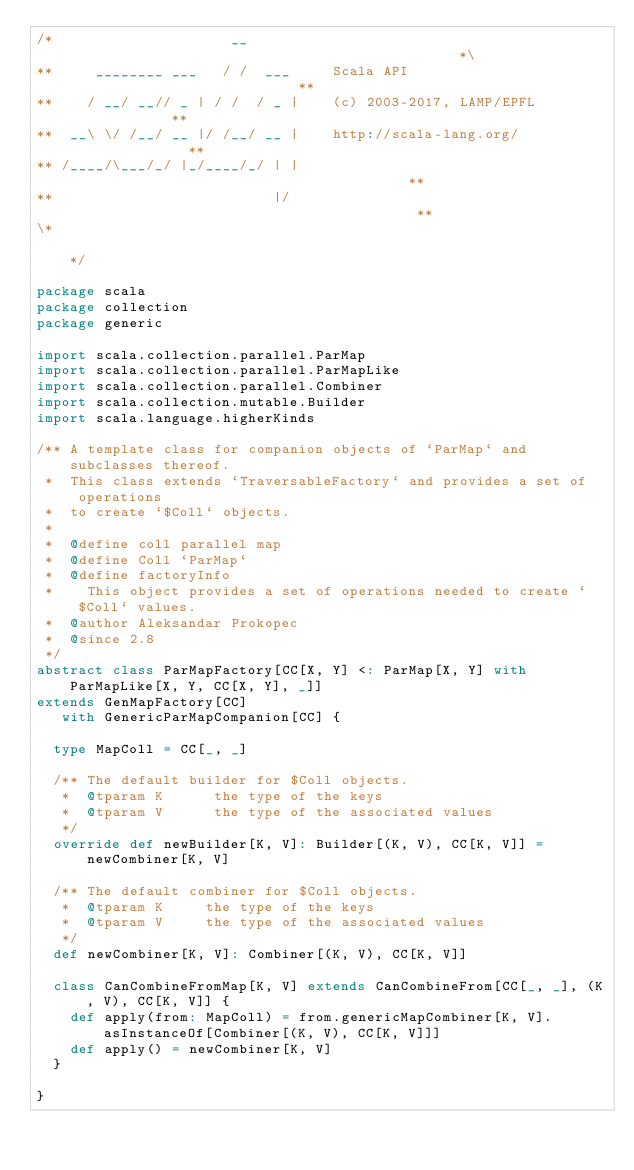<code> <loc_0><loc_0><loc_500><loc_500><_Scala_>/*                     __                                               *\
**     ________ ___   / /  ___     Scala API                            **
**    / __/ __// _ | / /  / _ |    (c) 2003-2017, LAMP/EPFL             **
**  __\ \/ /__/ __ |/ /__/ __ |    http://scala-lang.org/               **
** /____/\___/_/ |_/____/_/ | |                                         **
**                          |/                                          **
\*                                                                      */

package scala
package collection
package generic

import scala.collection.parallel.ParMap
import scala.collection.parallel.ParMapLike
import scala.collection.parallel.Combiner
import scala.collection.mutable.Builder
import scala.language.higherKinds

/** A template class for companion objects of `ParMap` and subclasses thereof.
 *  This class extends `TraversableFactory` and provides a set of operations
 *  to create `$Coll` objects.
 *
 *  @define coll parallel map
 *  @define Coll `ParMap`
 *  @define factoryInfo
 *    This object provides a set of operations needed to create `$Coll` values.
 *  @author Aleksandar Prokopec
 *  @since 2.8
 */
abstract class ParMapFactory[CC[X, Y] <: ParMap[X, Y] with ParMapLike[X, Y, CC[X, Y], _]]
extends GenMapFactory[CC]
   with GenericParMapCompanion[CC] {

  type MapColl = CC[_, _]

  /** The default builder for $Coll objects.
   *  @tparam K      the type of the keys
   *  @tparam V      the type of the associated values
   */
  override def newBuilder[K, V]: Builder[(K, V), CC[K, V]] = newCombiner[K, V]

  /** The default combiner for $Coll objects.
   *  @tparam K     the type of the keys
   *  @tparam V     the type of the associated values
   */
  def newCombiner[K, V]: Combiner[(K, V), CC[K, V]]

  class CanCombineFromMap[K, V] extends CanCombineFrom[CC[_, _], (K, V), CC[K, V]] {
    def apply(from: MapColl) = from.genericMapCombiner[K, V].asInstanceOf[Combiner[(K, V), CC[K, V]]]
    def apply() = newCombiner[K, V]
  }

}

</code> 